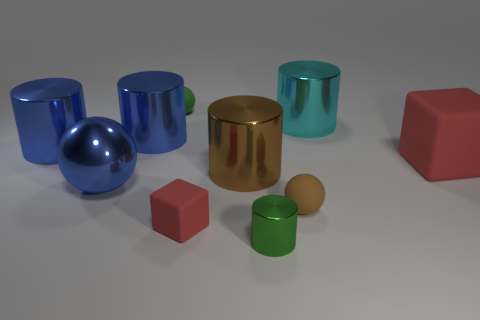What is the shape of the large cyan thing that is the same material as the large brown object?
Offer a terse response. Cylinder. Does the red object that is to the left of the brown cylinder have the same size as the large metal ball?
Your response must be concise. No. What number of objects are either metallic spheres left of the tiny green rubber ball or balls that are in front of the large red object?
Provide a succinct answer. 2. Do the cube that is right of the big brown metal cylinder and the metallic sphere have the same color?
Offer a very short reply. No. What number of metal objects are either purple blocks or small objects?
Your response must be concise. 1. What shape is the small shiny thing?
Keep it short and to the point. Cylinder. Is the material of the brown cylinder the same as the tiny green ball?
Give a very brief answer. No. Is there a object behind the green object right of the tiny green thing behind the cyan cylinder?
Offer a terse response. Yes. How many other things are the same shape as the big rubber thing?
Ensure brevity in your answer.  1. The large metallic thing that is right of the green rubber sphere and in front of the large cyan object has what shape?
Your answer should be compact. Cylinder. 